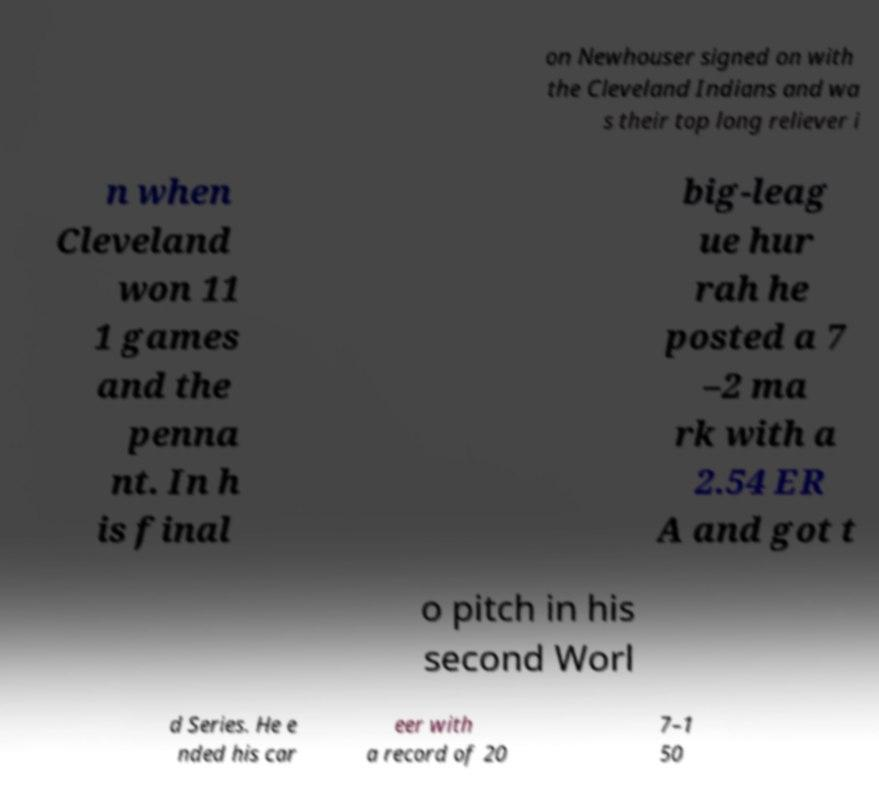Please identify and transcribe the text found in this image. on Newhouser signed on with the Cleveland Indians and wa s their top long reliever i n when Cleveland won 11 1 games and the penna nt. In h is final big-leag ue hur rah he posted a 7 –2 ma rk with a 2.54 ER A and got t o pitch in his second Worl d Series. He e nded his car eer with a record of 20 7–1 50 